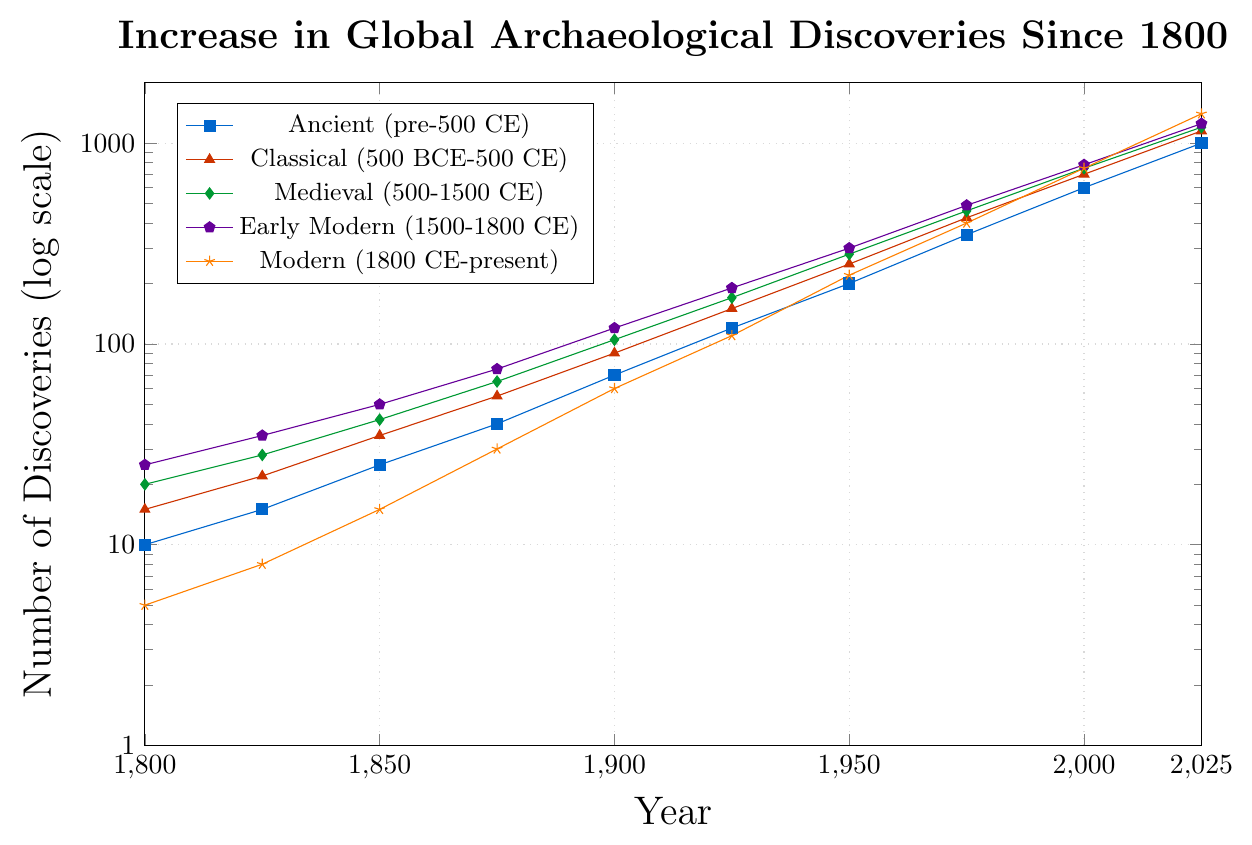What's the historical period with the highest number of discoveries in 2025? Look at the endpoints of each line in 2025. The Modern (1800 CE-present) period has the highest value.
Answer: Modern (1800 CE-present) How much did the number of discoveries increase for the Medieval period from 1850 to 1950? Find the value for the Medieval period at 1850 (42) and 1950 (280). The increase is 280 - 42 = 238.
Answer: 238 Which historical period shows the maximum number of discoveries in 1900? Check the values for each period in 1900. The Early Modern (1500-1800 CE) period has the highest number of discoveries at 120.
Answer: Early Modern (1500-1800 CE) By how much did the number of Classical period discoveries increase between 1975 and 2025? The number of Classical period discoveries in 1975 is 425 and in 2025 is 1150. The increase is 1150 - 425 = 725.
Answer: 725 Compare the discovery rates of the Ancient and Early Modern periods between 1900 and 1950. Which period saw a higher increase? For the Ancient period, the increase is from 70 to 200, which is 200 - 70 = 130. For the Early Modern period, the increase is from 120 to 300, which is 300 - 120 = 180. Early Modern (1500-1800 CE) period saw a higher increase.
Answer: Early Modern (1500-1800 CE) Which period had the steepest increase in discoveries between 2000 and 2025? Compare the line slopes between 2000 and 2025. The Modern (1800 CE-present) period has the steepest increase, going from 750 to 1400.
Answer: Modern (1800 CE-present) What is the total number of discoveries by 2025 for all periods combined? Sum the values for 2025 (1000 + 1150 + 1200 + 1250 + 1400). The total is 1000 + 1150 + 1200 + 1250 + 1400 = 6000.
Answer: 6000 How does the number of discoveries in 1850 for the Ancient period compare to the Modern period? The number of discoveries in the Ancient period is 25 and in the Modern period is 15. The Ancient period had 10 more discoveries than the Modern period.
Answer: The Ancient period had 10 more discoveries Which period had the most consistent increase in discoveries from 1800 to 2025? Consistency can be judged by a smooth and steep slope without any sudden jumps or drops. The Ancient (pre-500 CE) period appears to have the most consistent increase.
Answer: Ancient (pre-500 CE) 